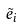<formula> <loc_0><loc_0><loc_500><loc_500>\tilde { e } _ { i }</formula> 